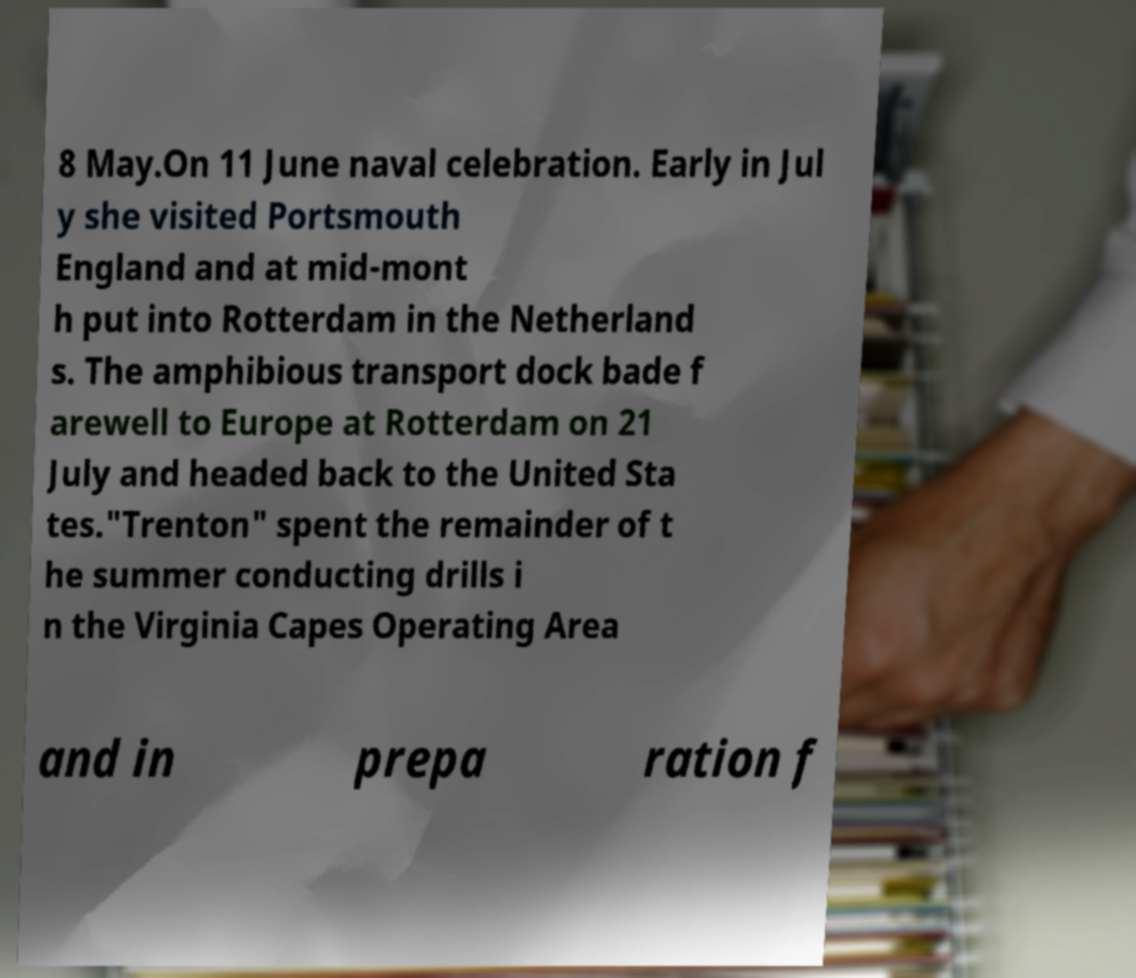There's text embedded in this image that I need extracted. Can you transcribe it verbatim? 8 May.On 11 June naval celebration. Early in Jul y she visited Portsmouth England and at mid-mont h put into Rotterdam in the Netherland s. The amphibious transport dock bade f arewell to Europe at Rotterdam on 21 July and headed back to the United Sta tes."Trenton" spent the remainder of t he summer conducting drills i n the Virginia Capes Operating Area and in prepa ration f 